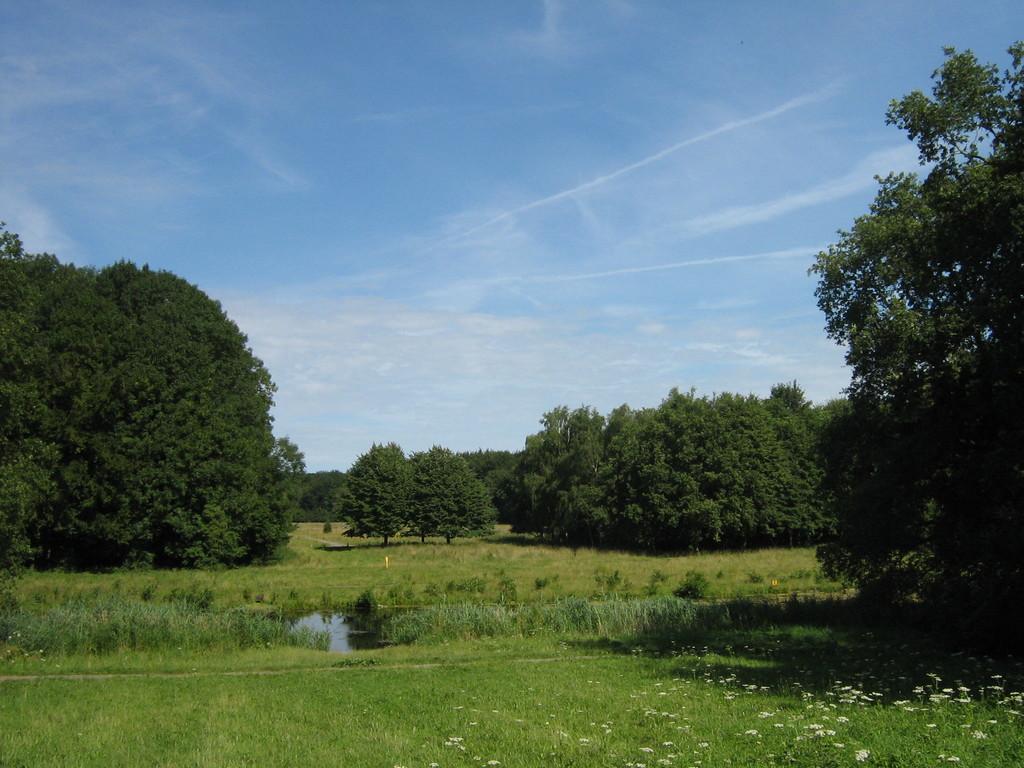Can you describe this image briefly? In this picture we can see some water, grass, trees and few flowers to the plants. 